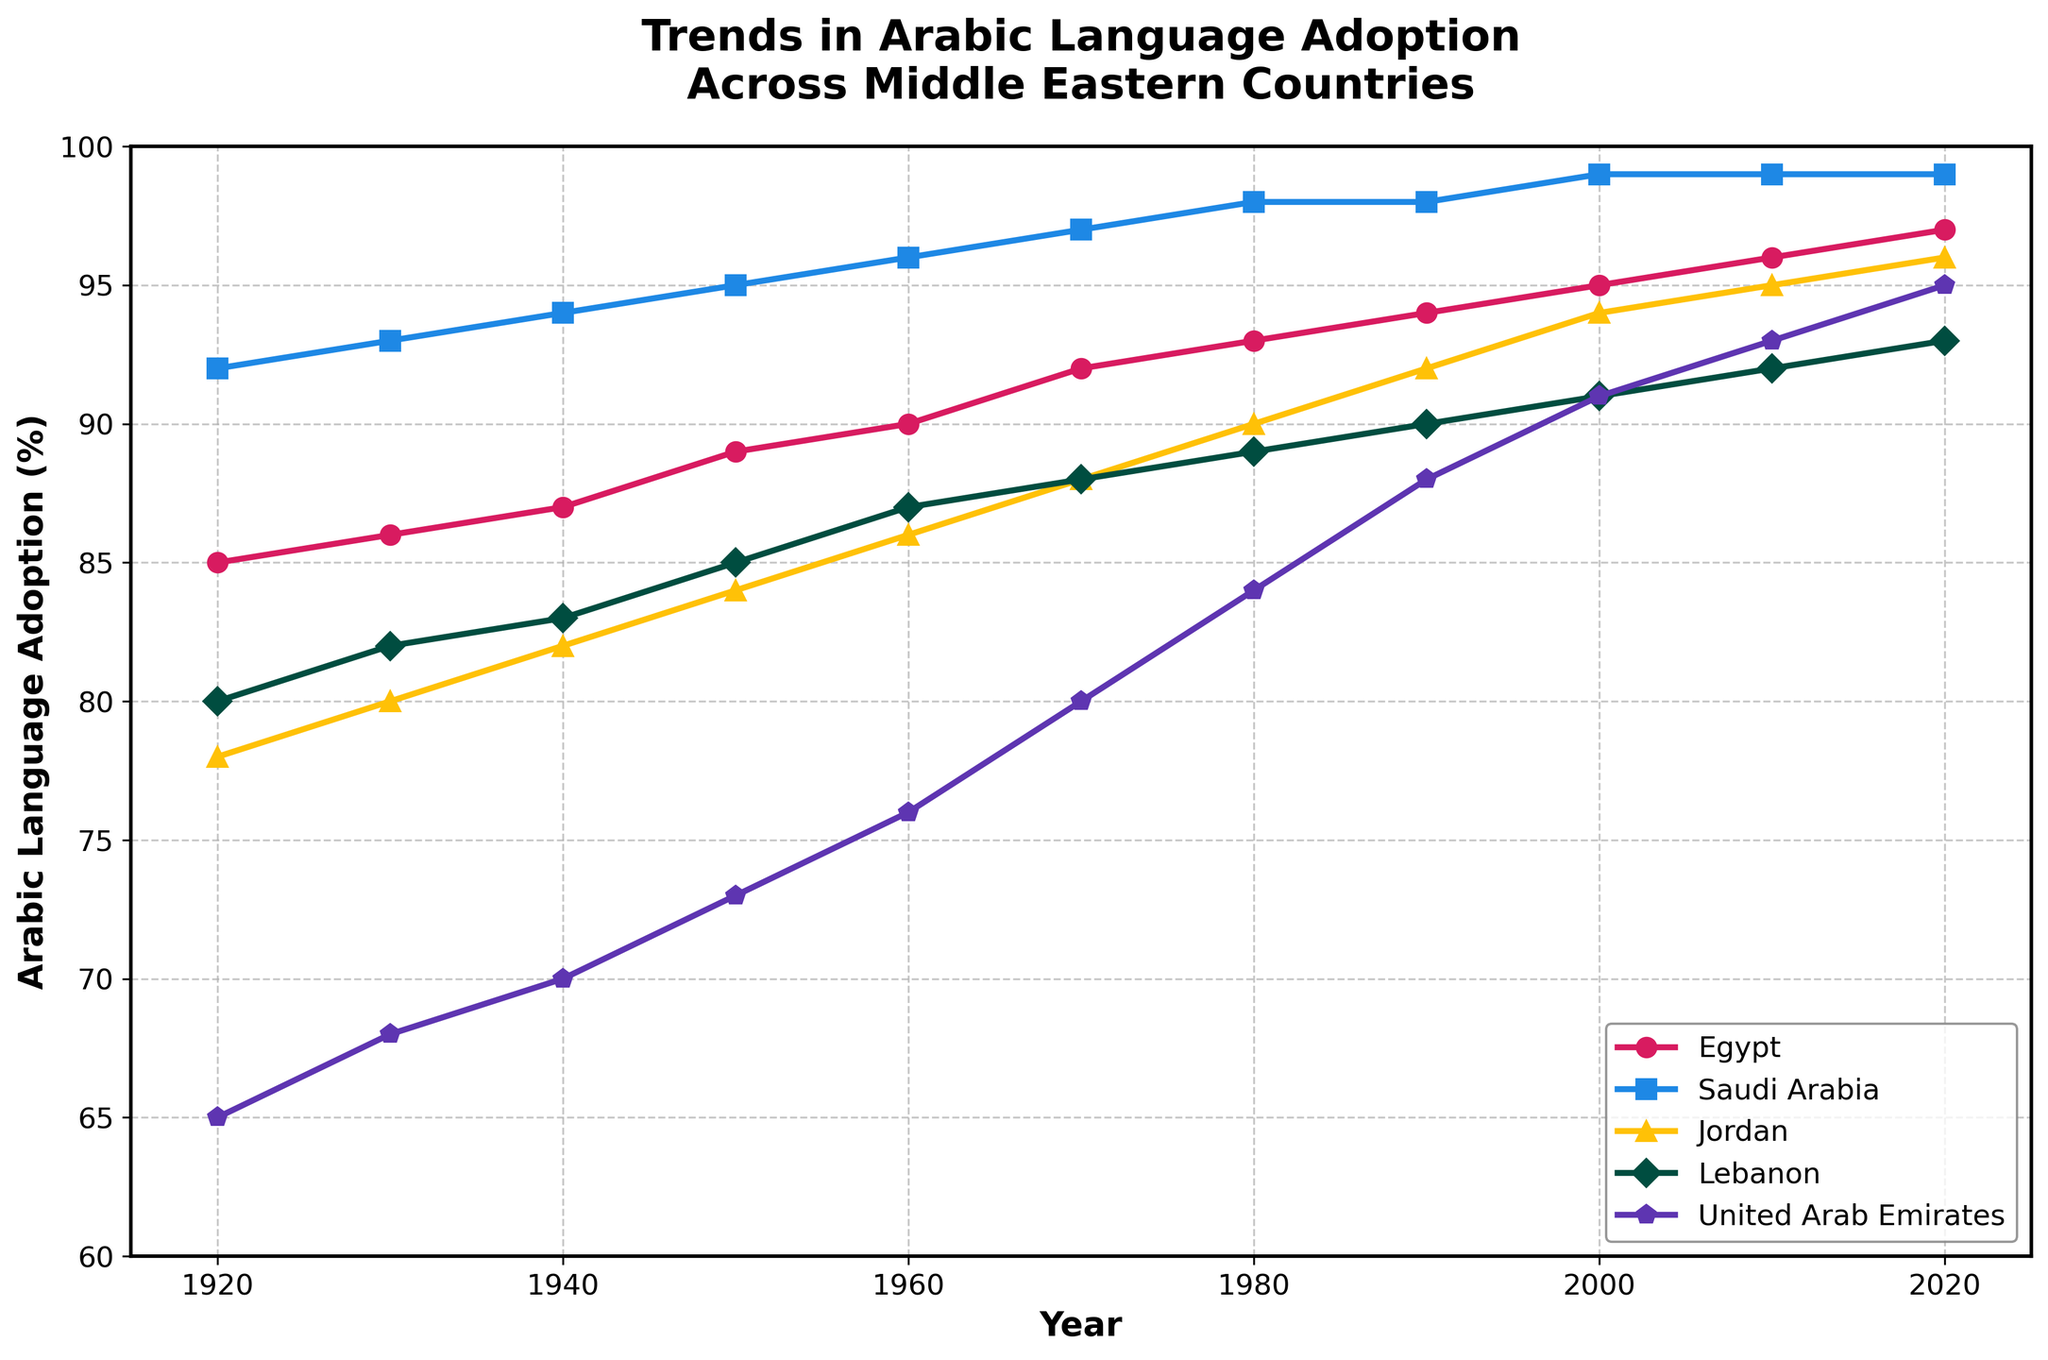What's the general trend in Arabic language adoption in Egypt over the past century? The plot shows a steady increase in Arabic language adoption in Egypt from 85% in 1920 to 97% in 2020. I observe a smooth upward trend without any drops.
Answer: Steady increase Comparing the year 1960, which country had the highest and which country had the lowest Arabic language adoption? In 1960, Saudi Arabia had the highest adoption at 96%, while the United Arab Emirates had the lowest adoption at 76%. This is determined by reading the values for each country at the 1960 mark on the x-axis.
Answer: Saudi Arabia highest, UAE lowest How did Arabic language adoption in Lebanon change between 1980 and 2020? From 1980 to 2020, Lebanon saw an increase in Arabic language adoption from 89% to 93%. By examining the values at the years 1980 and 2020 on the plot, we can observe a gradual increase.
Answer: Increased by 4% Which country showed the fastest initial increase in Arabic language adoption from 1920 to 1940? By looking at the steepness of the lines between 1920 and 1940, Saudi Arabia showed the fastest initial increase growing from 92% to 94%.
Answer: Saudi Arabia Is there any country where the Arabic language adoption remained constant for a decade? In Saudi Arabia, the adoption rate remained constant at 98% from 1980 to 1990 and again from 2010 to 2020. We can see these plateaus on the plot by looking at the flat parts of the line corresponding to Saudi Arabia.
Answer: Saudi Arabia What's the overall difference in Arabic language adoption between United Arab Emirates and Egypt in 1920 and 2020? In 1920, UAE was at 65% and Egypt was at 85%, a difference of 20%. In 2020, UAE was at 95% and Egypt was at 97%, a difference of 2%. The differences are obtained by subtracting the values for Egypt and UAE at each year from one another. The overall change in difference is 20% - 2% = 18%.
Answer: 18% decrease Which country had the smallest percentage change in Arabic language adoption from 1920 to 2020? To find this, calculate the difference between the adoption percentages for 1920 and 2020 for each country and then compare these differences. Lebanon had the smallest percentage change: 93% in 2020 minus 80% in 1920 equals a 13% increase.
Answer: Lebanon How does the rate of change in Arabic language adoption for Jordan from 1980 to 2000 compare to that of Egypt in the same period? For Jordan, the rate of change from 1980 (90%) to 2000 (94%) is 4%. For Egypt, the change from 1980 (93%) to 2000 (95%) is 2%. Comparing these changes, Jordan's adoption rate increased faster by 2%.
Answer: Jordan increased faster by 2% Which country's line is marked with a star and what does it represent? Jordan's line is marked with a star, and the marker represents data points for Jordan over the years. Visual attributes such as marker shapes can be used to differentiate between lines.
Answer: Jordan 